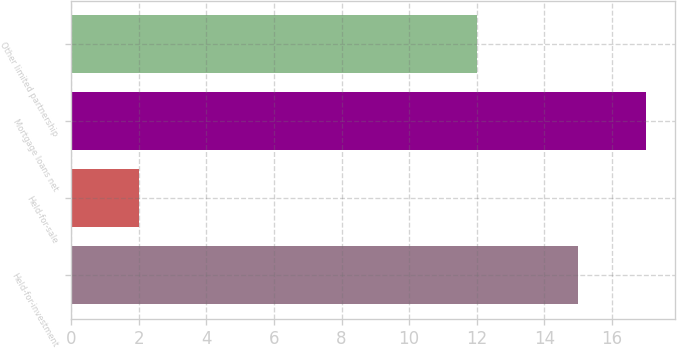<chart> <loc_0><loc_0><loc_500><loc_500><bar_chart><fcel>Held-for-investment<fcel>Held-for-sale<fcel>Mortgage loans net<fcel>Other limited partnership<nl><fcel>15<fcel>2<fcel>17<fcel>12<nl></chart> 